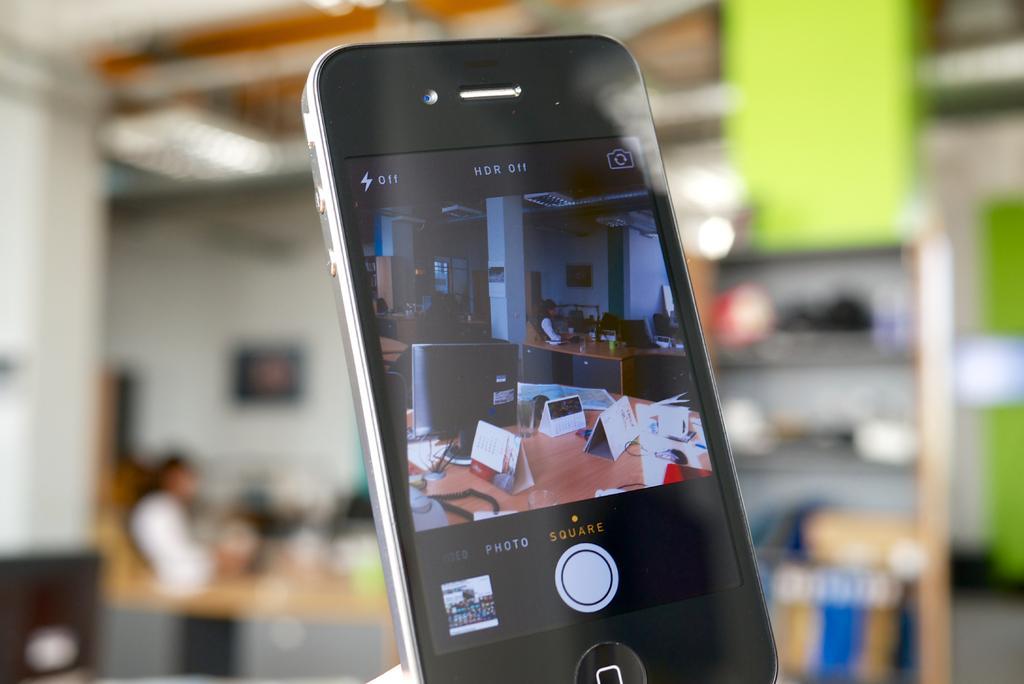How would you summarize this image in a sentence or two? In this image there is a mobile phone towards the bottom of the image, there is a person, there is a wall, there is a photo frame on the wall, there is a shelf, there are objects on the shelf, there is wall towards the left of the image, there is roof towards the top of the image, there is an object towards the top of the image, there is an object towards the right of the image, the background of the image is blurred. 